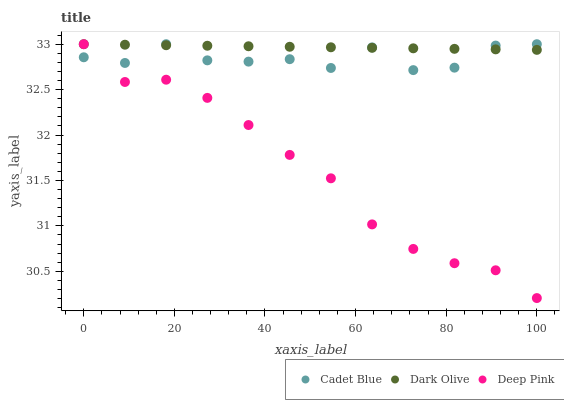Does Deep Pink have the minimum area under the curve?
Answer yes or no. Yes. Does Dark Olive have the maximum area under the curve?
Answer yes or no. Yes. Does Cadet Blue have the minimum area under the curve?
Answer yes or no. No. Does Cadet Blue have the maximum area under the curve?
Answer yes or no. No. Is Dark Olive the smoothest?
Answer yes or no. Yes. Is Cadet Blue the roughest?
Answer yes or no. Yes. Is Deep Pink the smoothest?
Answer yes or no. No. Is Deep Pink the roughest?
Answer yes or no. No. Does Deep Pink have the lowest value?
Answer yes or no. Yes. Does Cadet Blue have the lowest value?
Answer yes or no. No. Does Deep Pink have the highest value?
Answer yes or no. Yes. Does Cadet Blue intersect Dark Olive?
Answer yes or no. Yes. Is Cadet Blue less than Dark Olive?
Answer yes or no. No. Is Cadet Blue greater than Dark Olive?
Answer yes or no. No. 